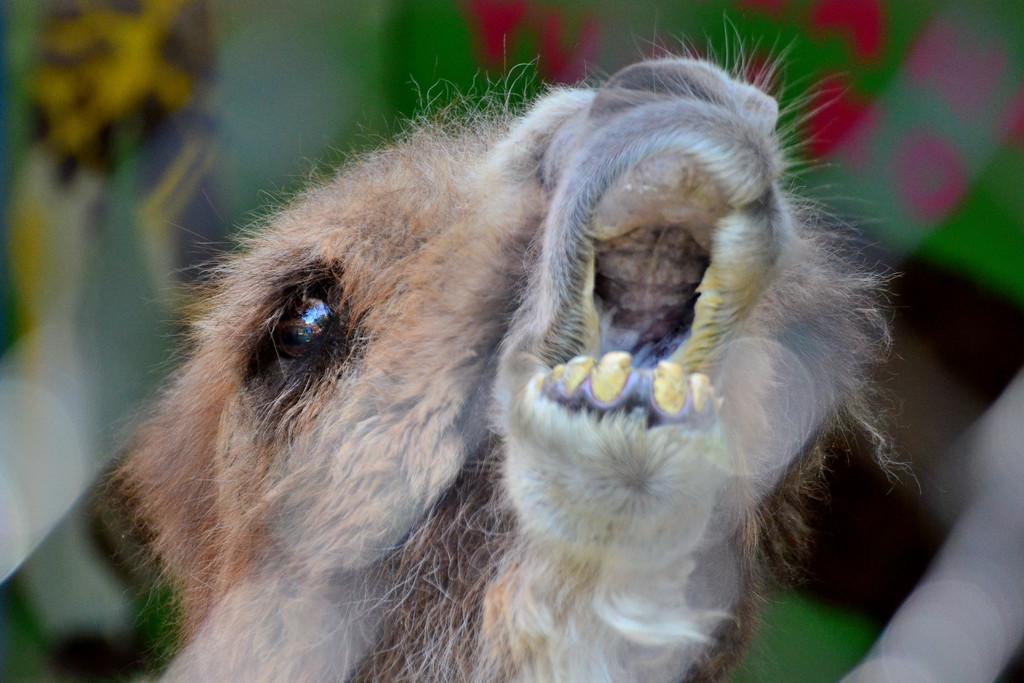Describe this image in one or two sentences. In front of the image there is some animal and the background of the image is blur. 